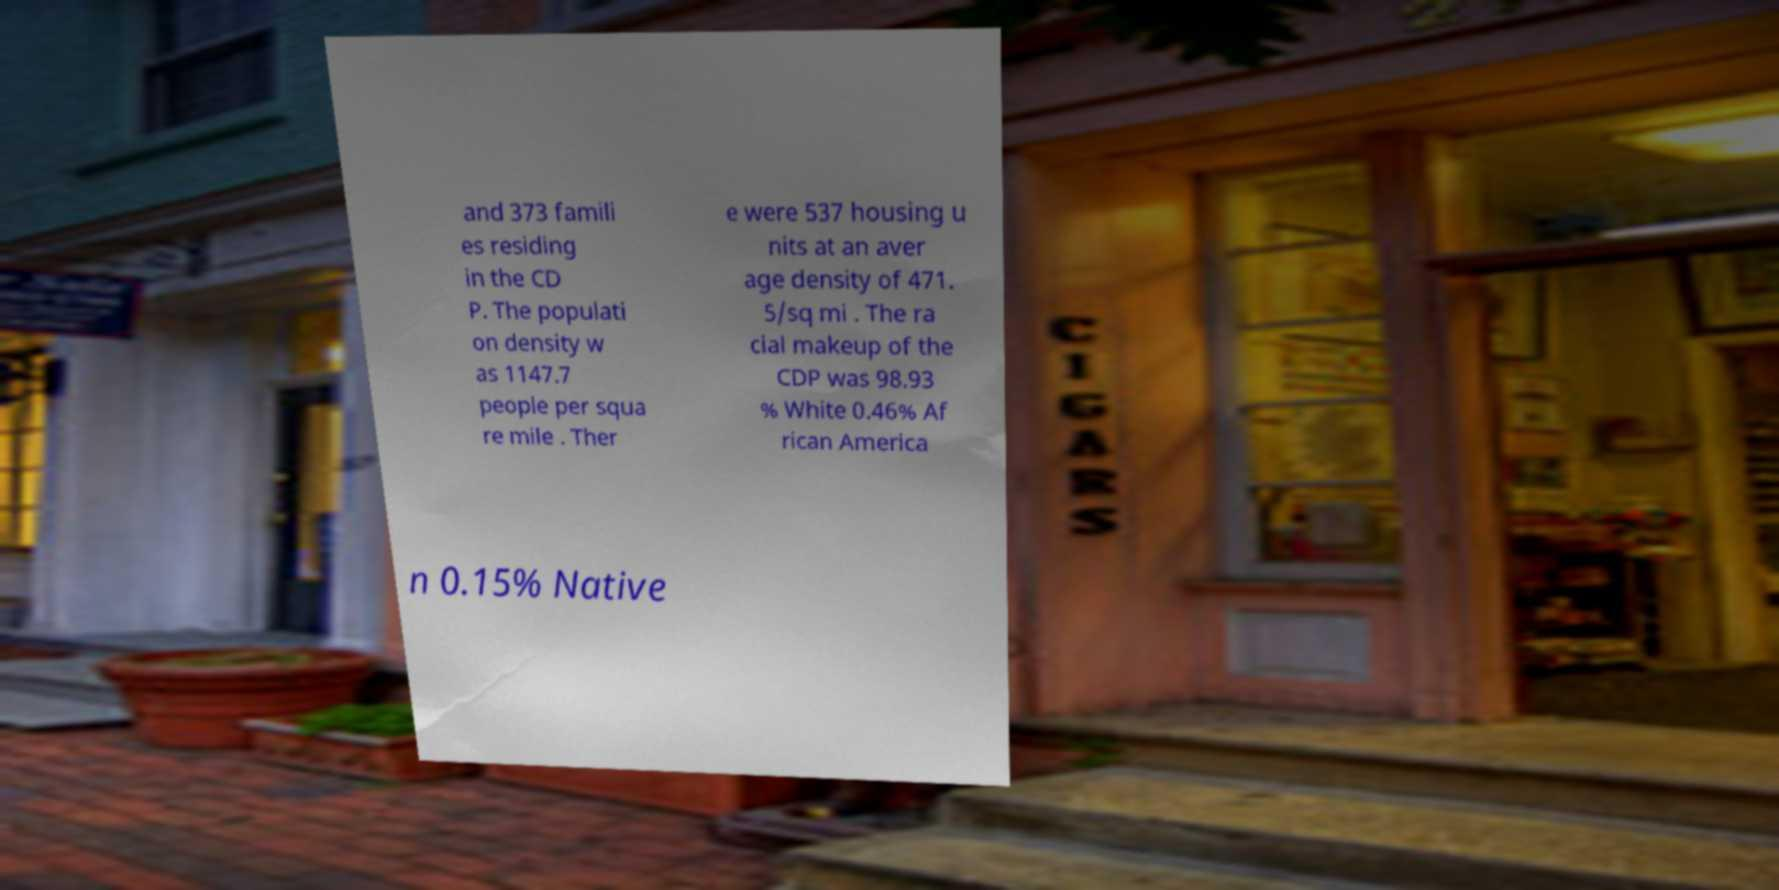Can you read and provide the text displayed in the image?This photo seems to have some interesting text. Can you extract and type it out for me? and 373 famili es residing in the CD P. The populati on density w as 1147.7 people per squa re mile . Ther e were 537 housing u nits at an aver age density of 471. 5/sq mi . The ra cial makeup of the CDP was 98.93 % White 0.46% Af rican America n 0.15% Native 